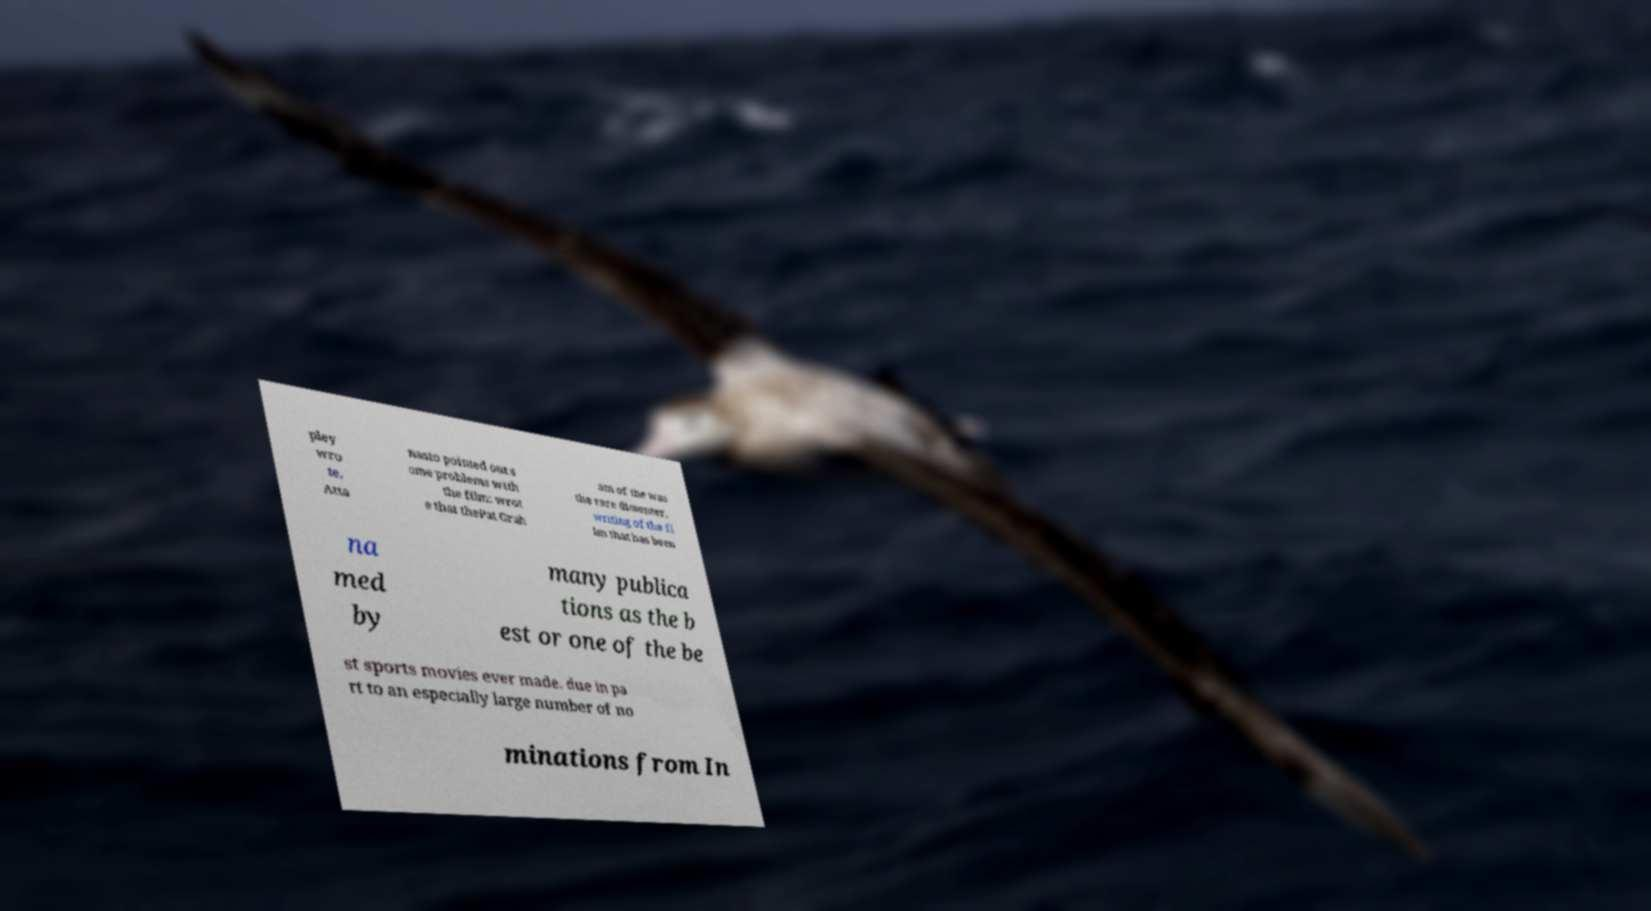I need the written content from this picture converted into text. Can you do that? pley wro te, Atta nasio pointed out s ome problems with the film: wrot e that thePat Grah am of the was the rare dissenter, writing of the fi lm that has been na med by many publica tions as the b est or one of the be st sports movies ever made. due in pa rt to an especially large number of no minations from In 